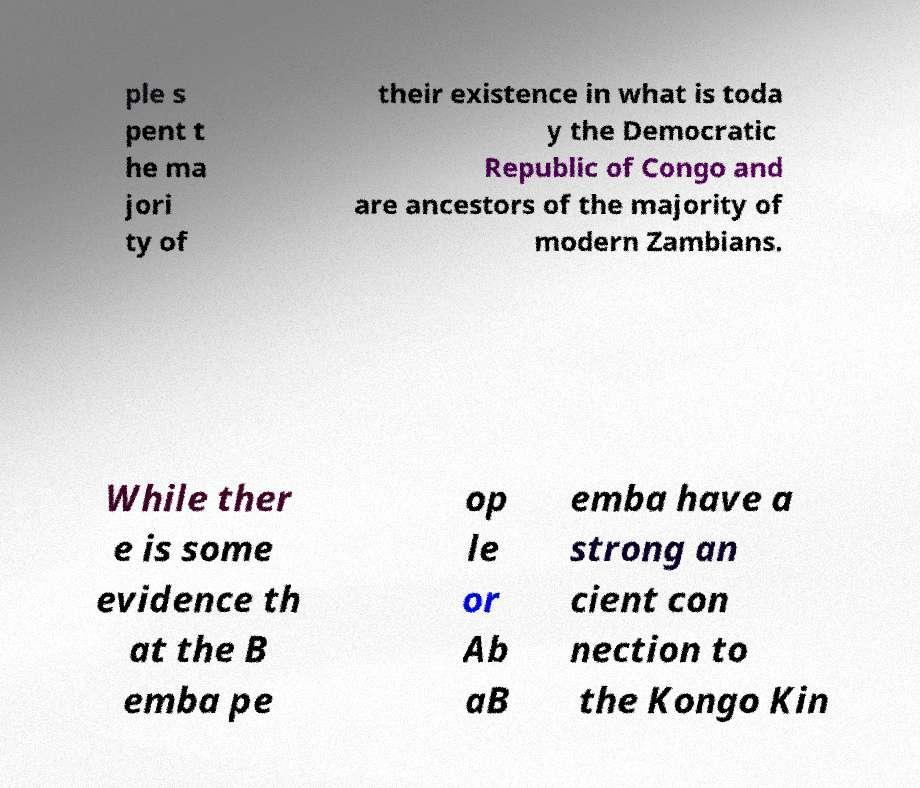For documentation purposes, I need the text within this image transcribed. Could you provide that? ple s pent t he ma jori ty of their existence in what is toda y the Democratic Republic of Congo and are ancestors of the majority of modern Zambians. While ther e is some evidence th at the B emba pe op le or Ab aB emba have a strong an cient con nection to the Kongo Kin 